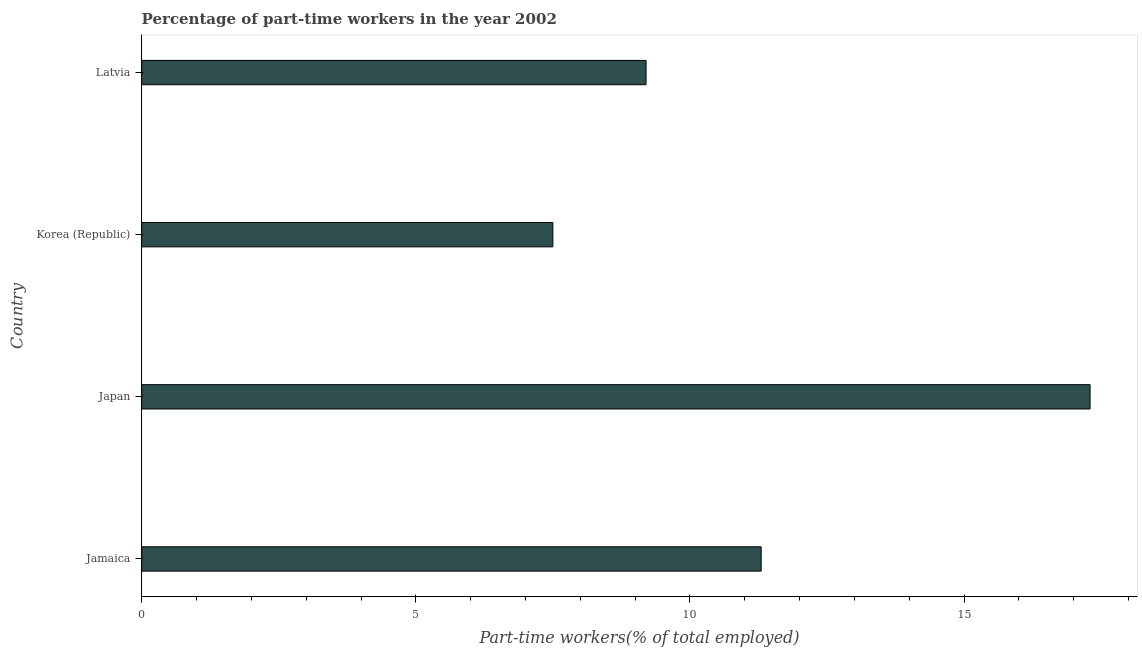What is the title of the graph?
Make the answer very short. Percentage of part-time workers in the year 2002. What is the label or title of the X-axis?
Your answer should be compact. Part-time workers(% of total employed). What is the label or title of the Y-axis?
Provide a succinct answer. Country. What is the percentage of part-time workers in Japan?
Offer a very short reply. 17.3. Across all countries, what is the maximum percentage of part-time workers?
Your response must be concise. 17.3. In which country was the percentage of part-time workers maximum?
Provide a succinct answer. Japan. In which country was the percentage of part-time workers minimum?
Provide a succinct answer. Korea (Republic). What is the sum of the percentage of part-time workers?
Ensure brevity in your answer.  45.3. What is the average percentage of part-time workers per country?
Provide a short and direct response. 11.32. What is the median percentage of part-time workers?
Make the answer very short. 10.25. What is the ratio of the percentage of part-time workers in Jamaica to that in Korea (Republic)?
Your answer should be compact. 1.51. Is the percentage of part-time workers in Japan less than that in Korea (Republic)?
Provide a succinct answer. No. Is the difference between the percentage of part-time workers in Korea (Republic) and Latvia greater than the difference between any two countries?
Your answer should be compact. No. What is the difference between the highest and the second highest percentage of part-time workers?
Offer a terse response. 6. What is the difference between the highest and the lowest percentage of part-time workers?
Provide a succinct answer. 9.8. How many bars are there?
Offer a very short reply. 4. Are all the bars in the graph horizontal?
Ensure brevity in your answer.  Yes. What is the difference between two consecutive major ticks on the X-axis?
Your answer should be very brief. 5. Are the values on the major ticks of X-axis written in scientific E-notation?
Your answer should be compact. No. What is the Part-time workers(% of total employed) of Jamaica?
Keep it short and to the point. 11.3. What is the Part-time workers(% of total employed) of Japan?
Your answer should be compact. 17.3. What is the Part-time workers(% of total employed) in Korea (Republic)?
Ensure brevity in your answer.  7.5. What is the Part-time workers(% of total employed) in Latvia?
Offer a very short reply. 9.2. What is the difference between the Part-time workers(% of total employed) in Jamaica and Japan?
Your response must be concise. -6. What is the difference between the Part-time workers(% of total employed) in Jamaica and Korea (Republic)?
Give a very brief answer. 3.8. What is the difference between the Part-time workers(% of total employed) in Jamaica and Latvia?
Provide a short and direct response. 2.1. What is the difference between the Part-time workers(% of total employed) in Japan and Latvia?
Your answer should be very brief. 8.1. What is the difference between the Part-time workers(% of total employed) in Korea (Republic) and Latvia?
Offer a terse response. -1.7. What is the ratio of the Part-time workers(% of total employed) in Jamaica to that in Japan?
Give a very brief answer. 0.65. What is the ratio of the Part-time workers(% of total employed) in Jamaica to that in Korea (Republic)?
Your response must be concise. 1.51. What is the ratio of the Part-time workers(% of total employed) in Jamaica to that in Latvia?
Make the answer very short. 1.23. What is the ratio of the Part-time workers(% of total employed) in Japan to that in Korea (Republic)?
Keep it short and to the point. 2.31. What is the ratio of the Part-time workers(% of total employed) in Japan to that in Latvia?
Offer a terse response. 1.88. What is the ratio of the Part-time workers(% of total employed) in Korea (Republic) to that in Latvia?
Offer a very short reply. 0.81. 